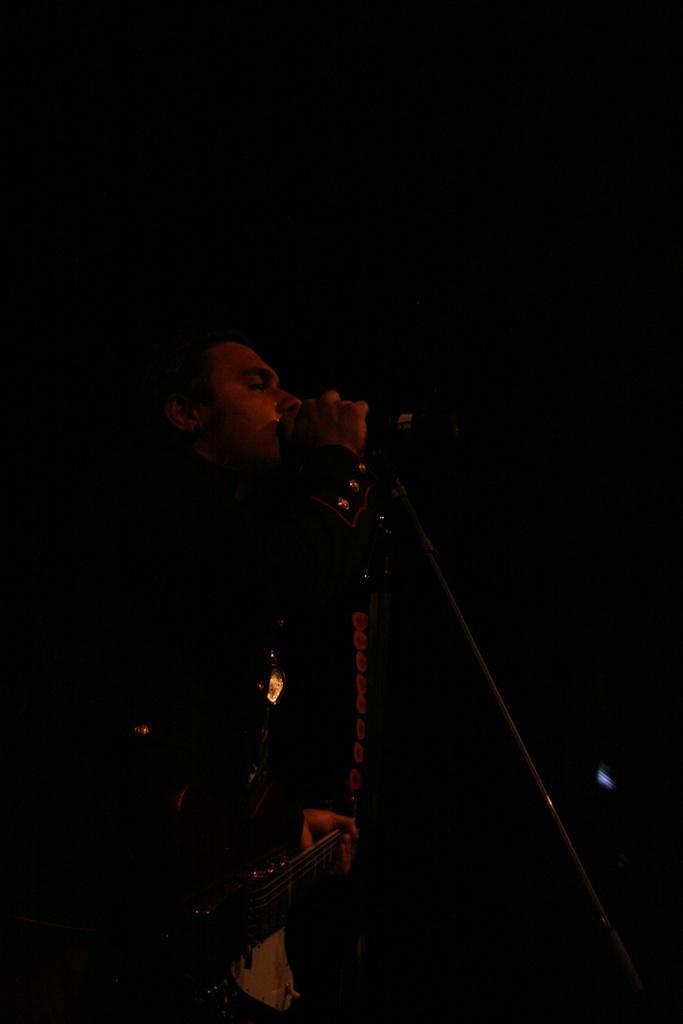Describe this image in one or two sentences. There is a person holding a guitar in his hand and singing in front of a mic. 